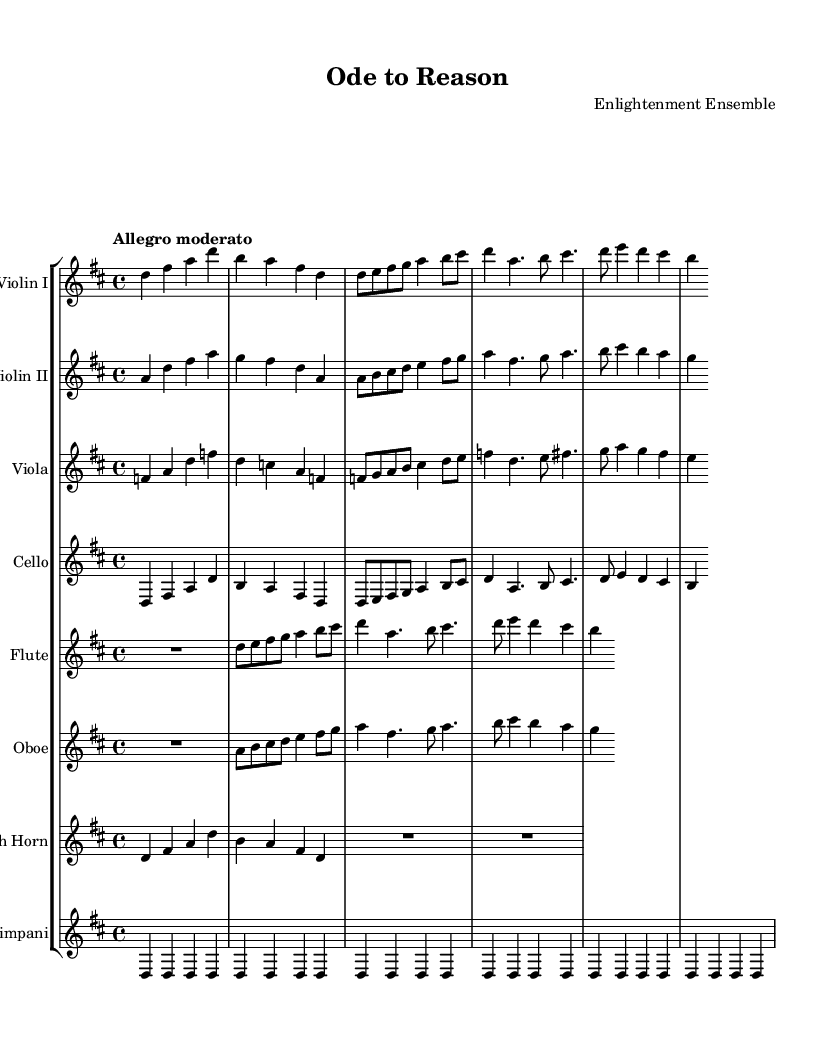What is the key signature of this music? The key signature is D major, as indicated by the presence of two sharps (F# and C#) in the key signature at the beginning of the sheet music.
Answer: D major What is the time signature of this music? The time signature is 4/4, shown at the beginning of the piece, indicating there are four beats in a measure and a quarter note gets one beat.
Answer: 4/4 What is the tempo marking of the symphony? The tempo marking is "Allegro moderato," which indicates a moderately fast pace. This term specifies how quickly the piece should be played.
Answer: Allegro moderato How many themes are presented in the composition? There are two distinct themes: Theme A and Theme B, which can be identified in the sections labeled in the music and highlighted in the individual parts for clarity.
Answer: 2 Which instrument has a rest in the introduction? The flute has a whole rest in the introduction, indicated by the symbol 'R1' which signifies no sound for the duration of that measure.
Answer: Flute What is the role of the timpani in this piece? The timpani plays a sustained note (D) throughout the introduction and themes, providing a foundational rhythmic and harmonic support that emphasizes the tonal center of the composition.
Answer: Rhythmic support Which instrument plays Theme A first? The first instrument to play Theme A is the violin I, which initiates the theme in a manner that establishes the character of the piece from the beginning.
Answer: Violin I 